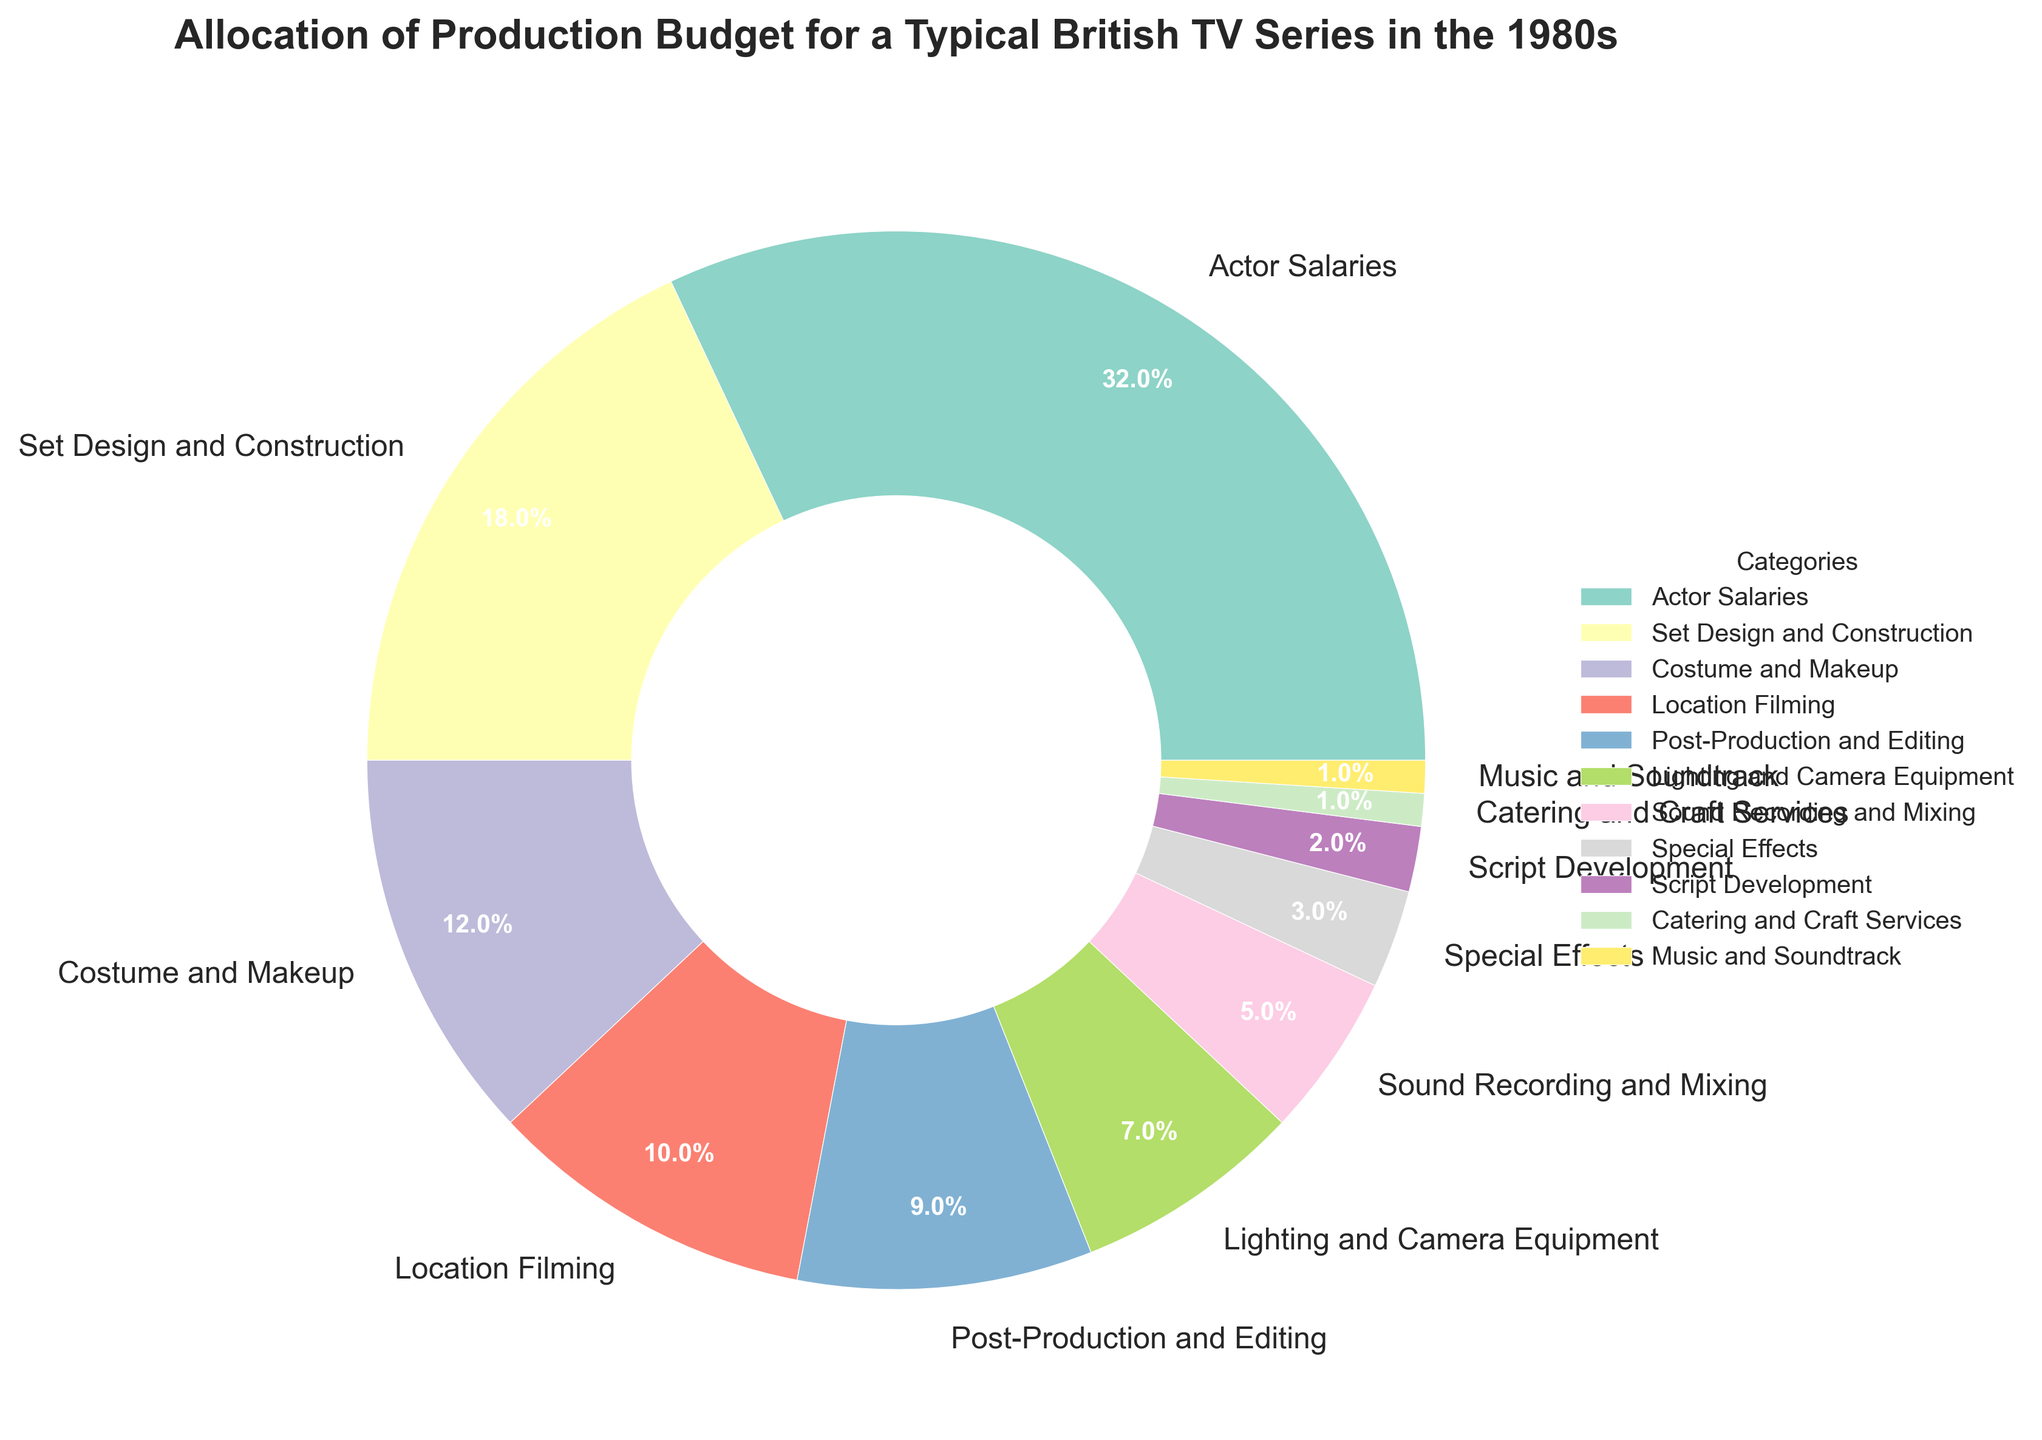Who has the largest allocation in the budget? By looking at the pie chart, the segment with the largest percentage represents Actor Salaries, making it the largest allocation in the budget.
Answer: Actor Salaries What percentages together make up the total spent on Set Design and Construction and Costume and Makeup? Set Design and Construction is 18% and Costume and Makeup is 12%. Adding these gives 18 + 12 = 30%.
Answer: 30% Which category has a higher budget allocation: Special Effects or Music and Soundtrack? Special Effects has a budget allocation of 3%, while Music and Soundtrack has 1%. Comparing these values, 3% is greater than 1%.
Answer: Special Effects Is the percentage spent on Lighting and Camera Equipment more or less than the percentage spent on Sound Recording and Mixing? Lighting and Camera Equipment has a percentage of 7%, whereas Sound Recording and Mixing has 5%. Since 7% is greater than 5%, Lighting and Camera Equipment has a larger allocation.
Answer: More What is the combined percentage allocation for Lighting and Camera Equipment, Sound Recording and Mixing, and Special Effects? Summing up the percentages of Lighting and Camera Equipment (7%), Sound Recording and Mixing (5%), and Special Effects (3%) gives 7 + 5 + 3 = 15%.
Answer: 15% Which category occupies a smaller percentage of the budget: Script Development or Catering and Craft Services? Script Development has 2%, while Catering and Craft Services has 1%. Since 1% is less than 2%, Catering and Craft Services occupies a smaller percentage of the budget.
Answer: Catering and Craft Services If you were to group Post-Production and Editing and Music and Soundtrack, what is the new total percentage? Post-Production and Editing has a percentage of 9% and Music and Soundtrack is 1%, adding these together gives 9 + 1 = 10%.
Answer: 10% Which category between Location Filming and Costume and Makeup has the higher budget allocation? By how much? Location Filming has a 10% allocation, and Costume and Makeup has 12%. The difference between them is 12 - 10 = 2%. Thus, Costume and Makeup has a higher allocation by 2%.
Answer: Costume and Makeup by 2% 